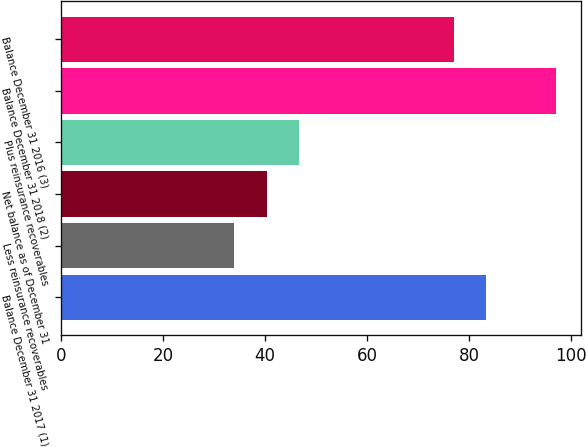Convert chart to OTSL. <chart><loc_0><loc_0><loc_500><loc_500><bar_chart><fcel>Balance December 31 2017 (1)<fcel>Less reinsurance recoverables<fcel>Net balance as of December 31<fcel>Plus reinsurance recoverables<fcel>Balance December 31 2018 (2)<fcel>Balance December 31 2016 (3)<nl><fcel>83.3<fcel>34<fcel>40.3<fcel>46.6<fcel>97<fcel>77<nl></chart> 